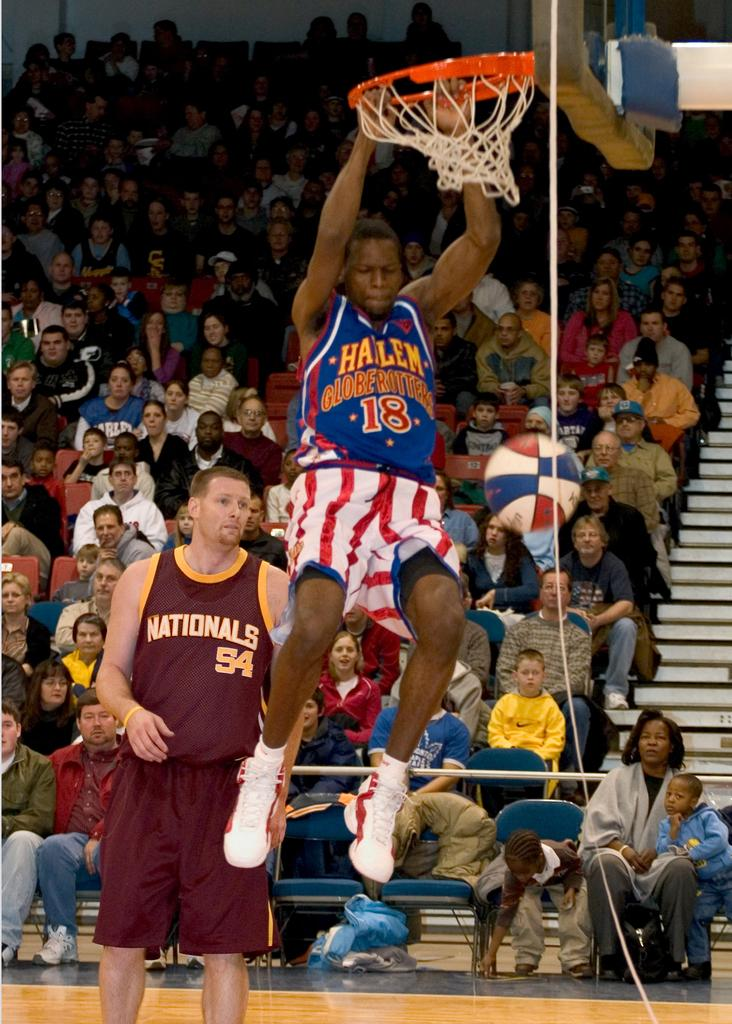What is the person in the foreground of the image doing? The person in the foreground of the image is hanging on a basketball net. Can you describe the person on the left side of the image? There is a person standing on the left side of the image. What can be seen in the background of the image? Many people are visible in the background of the image. What type of bait is the person using to catch fish in the image? There is no indication of fishing or bait in the image; it features a person hanging on a basketball net and another person standing nearby. 